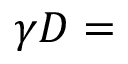<formula> <loc_0><loc_0><loc_500><loc_500>\gamma D =</formula> 